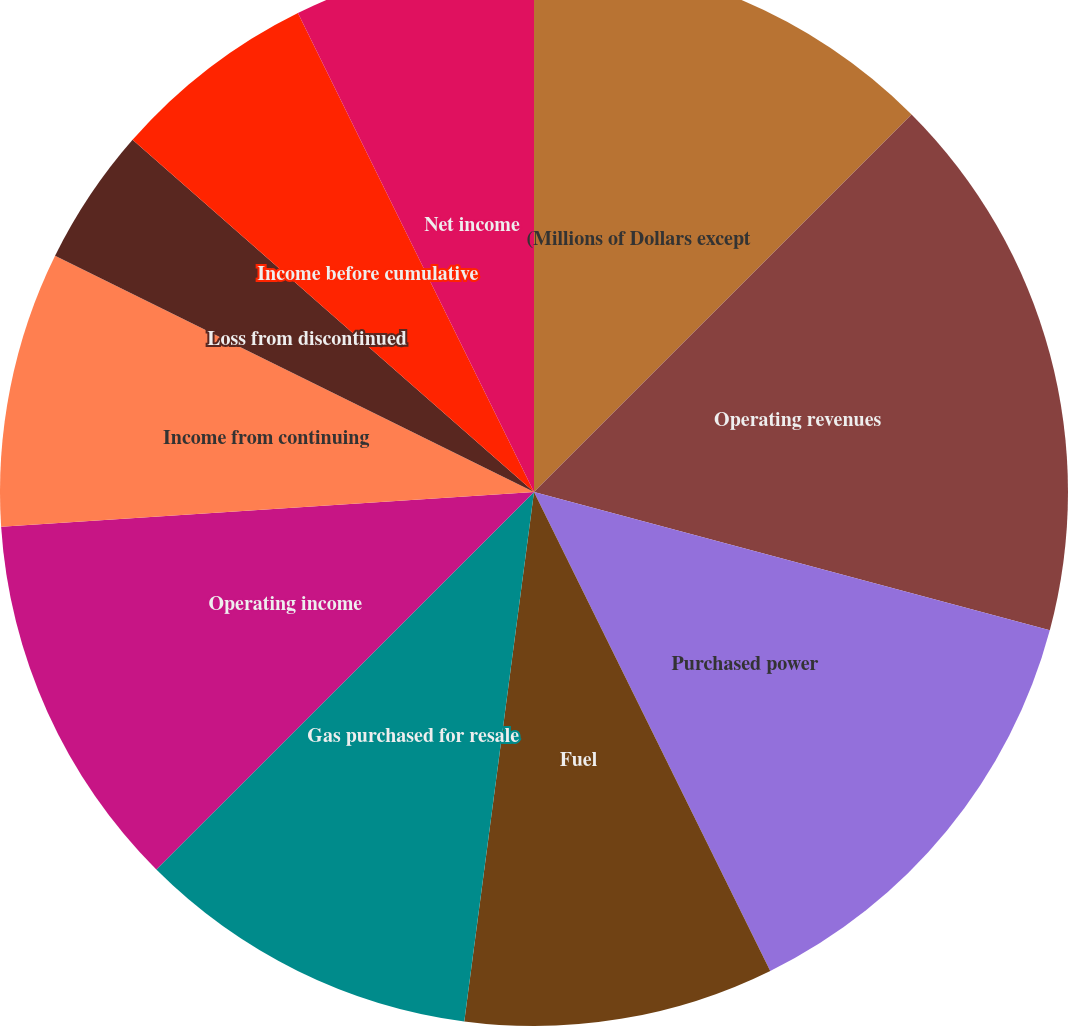<chart> <loc_0><loc_0><loc_500><loc_500><pie_chart><fcel>(Millions of Dollars except<fcel>Operating revenues<fcel>Purchased power<fcel>Fuel<fcel>Gas purchased for resale<fcel>Operating income<fcel>Income from continuing<fcel>Loss from discontinued<fcel>Income before cumulative<fcel>Net income<nl><fcel>12.5%<fcel>16.67%<fcel>13.54%<fcel>9.38%<fcel>10.42%<fcel>11.46%<fcel>8.33%<fcel>4.17%<fcel>6.25%<fcel>7.29%<nl></chart> 